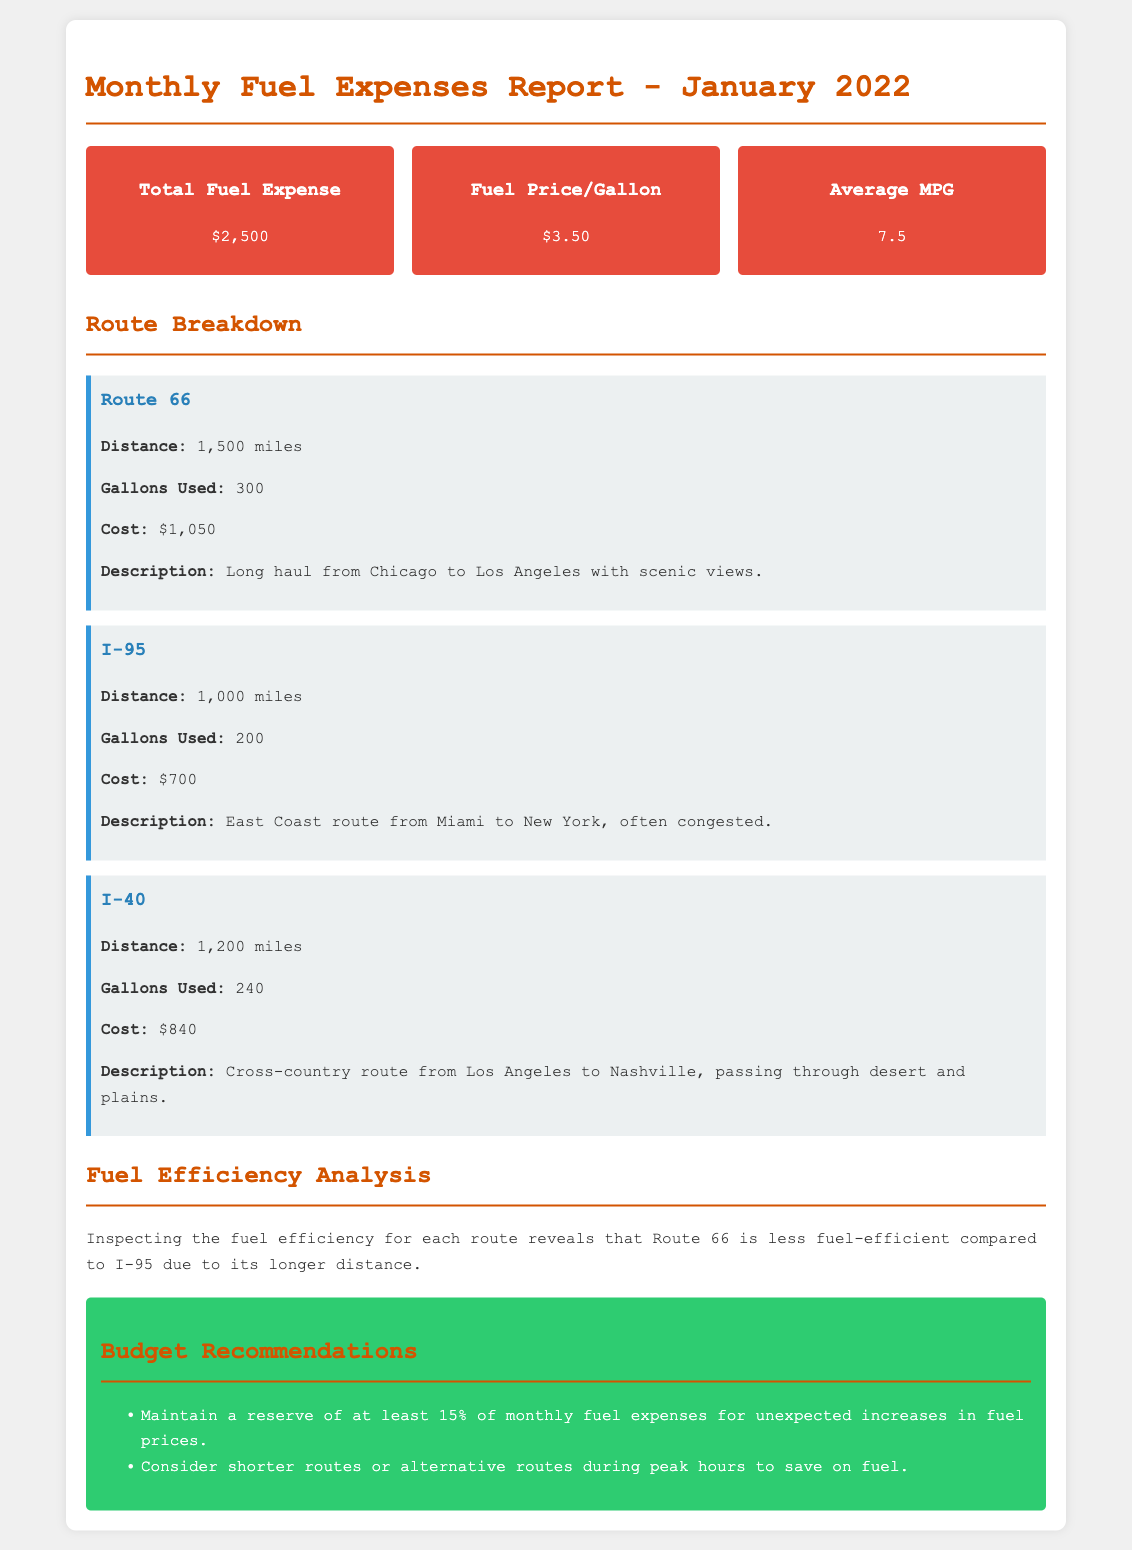What is the total fuel expense? The total fuel expense is explicitly stated in the document as $2,500.
Answer: $2,500 What is the cost of fuel per gallon? The document specifies the fuel price per gallon as $3.50.
Answer: $3.50 How many gallons were used on Route 66? The gallons used for Route 66 are listed in the breakdown as 300 gallons.
Answer: 300 What is the distance of the I-95 route? The distance for the I-95 route is provided as 1,000 miles in the breakdown.
Answer: 1,000 miles Which route had the highest fuel cost? The breakdown shows that Route 66 has the highest fuel cost at $1,050.
Answer: Route 66 What is the average miles per gallon (MPG)? The document indicates that the average MPG is 7.5.
Answer: 7.5 Which route has a description focusing on congestion? The description for I-95 highlights its congestion: "often congested."
Answer: I-95 What is the total distance covered by all routes combined? The total distance can be calculated by adding the distances of all routes: 1,500 + 1,000 + 1,200 = 3,700 miles.
Answer: 3,700 miles What budget recommendation is provided regarding fuel price increases? The document recommends maintaining a reserve of at least 15% for unexpected increases in fuel prices.
Answer: 15% 